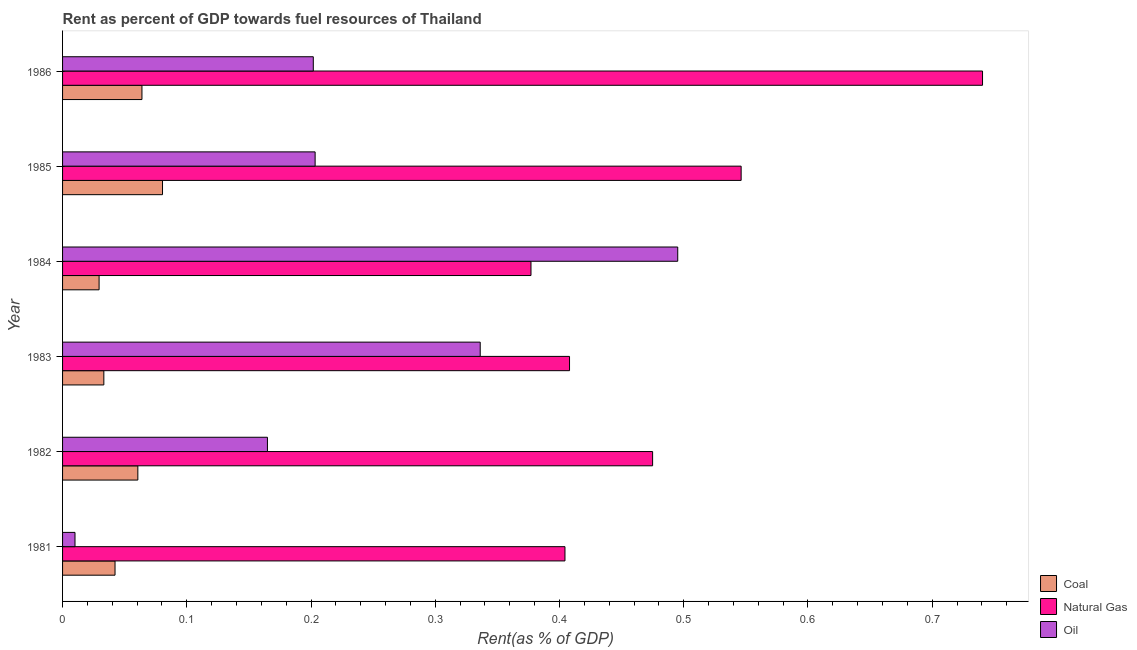How many different coloured bars are there?
Provide a short and direct response. 3. How many groups of bars are there?
Make the answer very short. 6. How many bars are there on the 5th tick from the top?
Make the answer very short. 3. In how many cases, is the number of bars for a given year not equal to the number of legend labels?
Make the answer very short. 0. What is the rent towards natural gas in 1983?
Give a very brief answer. 0.41. Across all years, what is the maximum rent towards oil?
Offer a very short reply. 0.5. Across all years, what is the minimum rent towards natural gas?
Your answer should be compact. 0.38. In which year was the rent towards oil minimum?
Give a very brief answer. 1981. What is the total rent towards coal in the graph?
Offer a terse response. 0.31. What is the difference between the rent towards coal in 1982 and that in 1983?
Provide a succinct answer. 0.03. What is the difference between the rent towards coal in 1984 and the rent towards oil in 1985?
Your answer should be very brief. -0.17. What is the average rent towards natural gas per year?
Give a very brief answer. 0.49. In the year 1981, what is the difference between the rent towards oil and rent towards coal?
Offer a terse response. -0.03. What is the ratio of the rent towards oil in 1982 to that in 1985?
Your response must be concise. 0.81. What is the difference between the highest and the second highest rent towards oil?
Your answer should be very brief. 0.16. What is the difference between the highest and the lowest rent towards natural gas?
Keep it short and to the point. 0.36. Is the sum of the rent towards natural gas in 1983 and 1985 greater than the maximum rent towards oil across all years?
Provide a succinct answer. Yes. What does the 2nd bar from the top in 1981 represents?
Keep it short and to the point. Natural Gas. What does the 2nd bar from the bottom in 1982 represents?
Keep it short and to the point. Natural Gas. Is it the case that in every year, the sum of the rent towards coal and rent towards natural gas is greater than the rent towards oil?
Your response must be concise. No. How many bars are there?
Your answer should be very brief. 18. Are all the bars in the graph horizontal?
Provide a short and direct response. Yes. How many years are there in the graph?
Provide a short and direct response. 6. What is the difference between two consecutive major ticks on the X-axis?
Give a very brief answer. 0.1. Are the values on the major ticks of X-axis written in scientific E-notation?
Keep it short and to the point. No. Does the graph contain any zero values?
Provide a succinct answer. No. Does the graph contain grids?
Your answer should be very brief. No. Where does the legend appear in the graph?
Make the answer very short. Bottom right. How are the legend labels stacked?
Provide a succinct answer. Vertical. What is the title of the graph?
Your answer should be compact. Rent as percent of GDP towards fuel resources of Thailand. What is the label or title of the X-axis?
Offer a terse response. Rent(as % of GDP). What is the label or title of the Y-axis?
Give a very brief answer. Year. What is the Rent(as % of GDP) of Coal in 1981?
Provide a short and direct response. 0.04. What is the Rent(as % of GDP) in Natural Gas in 1981?
Your answer should be compact. 0.4. What is the Rent(as % of GDP) of Oil in 1981?
Your answer should be compact. 0.01. What is the Rent(as % of GDP) of Coal in 1982?
Your answer should be very brief. 0.06. What is the Rent(as % of GDP) of Natural Gas in 1982?
Make the answer very short. 0.47. What is the Rent(as % of GDP) in Oil in 1982?
Make the answer very short. 0.16. What is the Rent(as % of GDP) in Coal in 1983?
Make the answer very short. 0.03. What is the Rent(as % of GDP) of Natural Gas in 1983?
Keep it short and to the point. 0.41. What is the Rent(as % of GDP) of Oil in 1983?
Make the answer very short. 0.34. What is the Rent(as % of GDP) of Coal in 1984?
Your answer should be compact. 0.03. What is the Rent(as % of GDP) of Natural Gas in 1984?
Your answer should be very brief. 0.38. What is the Rent(as % of GDP) of Oil in 1984?
Make the answer very short. 0.5. What is the Rent(as % of GDP) of Coal in 1985?
Keep it short and to the point. 0.08. What is the Rent(as % of GDP) of Natural Gas in 1985?
Keep it short and to the point. 0.55. What is the Rent(as % of GDP) in Oil in 1985?
Offer a very short reply. 0.2. What is the Rent(as % of GDP) of Coal in 1986?
Your response must be concise. 0.06. What is the Rent(as % of GDP) of Natural Gas in 1986?
Offer a terse response. 0.74. What is the Rent(as % of GDP) in Oil in 1986?
Your answer should be compact. 0.2. Across all years, what is the maximum Rent(as % of GDP) in Coal?
Keep it short and to the point. 0.08. Across all years, what is the maximum Rent(as % of GDP) in Natural Gas?
Provide a short and direct response. 0.74. Across all years, what is the maximum Rent(as % of GDP) in Oil?
Provide a short and direct response. 0.5. Across all years, what is the minimum Rent(as % of GDP) of Coal?
Provide a succinct answer. 0.03. Across all years, what is the minimum Rent(as % of GDP) in Natural Gas?
Keep it short and to the point. 0.38. Across all years, what is the minimum Rent(as % of GDP) in Oil?
Offer a terse response. 0.01. What is the total Rent(as % of GDP) in Coal in the graph?
Provide a short and direct response. 0.31. What is the total Rent(as % of GDP) in Natural Gas in the graph?
Make the answer very short. 2.95. What is the total Rent(as % of GDP) of Oil in the graph?
Keep it short and to the point. 1.41. What is the difference between the Rent(as % of GDP) of Coal in 1981 and that in 1982?
Make the answer very short. -0.02. What is the difference between the Rent(as % of GDP) of Natural Gas in 1981 and that in 1982?
Ensure brevity in your answer.  -0.07. What is the difference between the Rent(as % of GDP) of Oil in 1981 and that in 1982?
Ensure brevity in your answer.  -0.15. What is the difference between the Rent(as % of GDP) of Coal in 1981 and that in 1983?
Ensure brevity in your answer.  0.01. What is the difference between the Rent(as % of GDP) of Natural Gas in 1981 and that in 1983?
Your response must be concise. -0. What is the difference between the Rent(as % of GDP) of Oil in 1981 and that in 1983?
Ensure brevity in your answer.  -0.33. What is the difference between the Rent(as % of GDP) of Coal in 1981 and that in 1984?
Provide a succinct answer. 0.01. What is the difference between the Rent(as % of GDP) of Natural Gas in 1981 and that in 1984?
Your response must be concise. 0.03. What is the difference between the Rent(as % of GDP) in Oil in 1981 and that in 1984?
Make the answer very short. -0.49. What is the difference between the Rent(as % of GDP) of Coal in 1981 and that in 1985?
Your answer should be compact. -0.04. What is the difference between the Rent(as % of GDP) in Natural Gas in 1981 and that in 1985?
Offer a very short reply. -0.14. What is the difference between the Rent(as % of GDP) of Oil in 1981 and that in 1985?
Give a very brief answer. -0.19. What is the difference between the Rent(as % of GDP) in Coal in 1981 and that in 1986?
Provide a short and direct response. -0.02. What is the difference between the Rent(as % of GDP) of Natural Gas in 1981 and that in 1986?
Make the answer very short. -0.34. What is the difference between the Rent(as % of GDP) in Oil in 1981 and that in 1986?
Your answer should be compact. -0.19. What is the difference between the Rent(as % of GDP) in Coal in 1982 and that in 1983?
Your answer should be compact. 0.03. What is the difference between the Rent(as % of GDP) in Natural Gas in 1982 and that in 1983?
Your answer should be very brief. 0.07. What is the difference between the Rent(as % of GDP) in Oil in 1982 and that in 1983?
Your answer should be compact. -0.17. What is the difference between the Rent(as % of GDP) in Coal in 1982 and that in 1984?
Provide a short and direct response. 0.03. What is the difference between the Rent(as % of GDP) in Natural Gas in 1982 and that in 1984?
Offer a terse response. 0.1. What is the difference between the Rent(as % of GDP) in Oil in 1982 and that in 1984?
Offer a terse response. -0.33. What is the difference between the Rent(as % of GDP) in Coal in 1982 and that in 1985?
Make the answer very short. -0.02. What is the difference between the Rent(as % of GDP) in Natural Gas in 1982 and that in 1985?
Your answer should be compact. -0.07. What is the difference between the Rent(as % of GDP) of Oil in 1982 and that in 1985?
Keep it short and to the point. -0.04. What is the difference between the Rent(as % of GDP) of Coal in 1982 and that in 1986?
Make the answer very short. -0. What is the difference between the Rent(as % of GDP) in Natural Gas in 1982 and that in 1986?
Make the answer very short. -0.27. What is the difference between the Rent(as % of GDP) of Oil in 1982 and that in 1986?
Your answer should be compact. -0.04. What is the difference between the Rent(as % of GDP) of Coal in 1983 and that in 1984?
Provide a short and direct response. 0. What is the difference between the Rent(as % of GDP) in Natural Gas in 1983 and that in 1984?
Your answer should be very brief. 0.03. What is the difference between the Rent(as % of GDP) of Oil in 1983 and that in 1984?
Your response must be concise. -0.16. What is the difference between the Rent(as % of GDP) of Coal in 1983 and that in 1985?
Your answer should be compact. -0.05. What is the difference between the Rent(as % of GDP) of Natural Gas in 1983 and that in 1985?
Your response must be concise. -0.14. What is the difference between the Rent(as % of GDP) in Oil in 1983 and that in 1985?
Offer a terse response. 0.13. What is the difference between the Rent(as % of GDP) of Coal in 1983 and that in 1986?
Give a very brief answer. -0.03. What is the difference between the Rent(as % of GDP) in Natural Gas in 1983 and that in 1986?
Offer a terse response. -0.33. What is the difference between the Rent(as % of GDP) in Oil in 1983 and that in 1986?
Offer a very short reply. 0.13. What is the difference between the Rent(as % of GDP) in Coal in 1984 and that in 1985?
Offer a terse response. -0.05. What is the difference between the Rent(as % of GDP) in Natural Gas in 1984 and that in 1985?
Offer a terse response. -0.17. What is the difference between the Rent(as % of GDP) of Oil in 1984 and that in 1985?
Offer a terse response. 0.29. What is the difference between the Rent(as % of GDP) of Coal in 1984 and that in 1986?
Ensure brevity in your answer.  -0.03. What is the difference between the Rent(as % of GDP) in Natural Gas in 1984 and that in 1986?
Provide a succinct answer. -0.36. What is the difference between the Rent(as % of GDP) in Oil in 1984 and that in 1986?
Your answer should be very brief. 0.29. What is the difference between the Rent(as % of GDP) of Coal in 1985 and that in 1986?
Your response must be concise. 0.02. What is the difference between the Rent(as % of GDP) in Natural Gas in 1985 and that in 1986?
Give a very brief answer. -0.19. What is the difference between the Rent(as % of GDP) of Oil in 1985 and that in 1986?
Your answer should be compact. 0. What is the difference between the Rent(as % of GDP) of Coal in 1981 and the Rent(as % of GDP) of Natural Gas in 1982?
Offer a very short reply. -0.43. What is the difference between the Rent(as % of GDP) of Coal in 1981 and the Rent(as % of GDP) of Oil in 1982?
Provide a succinct answer. -0.12. What is the difference between the Rent(as % of GDP) in Natural Gas in 1981 and the Rent(as % of GDP) in Oil in 1982?
Keep it short and to the point. 0.24. What is the difference between the Rent(as % of GDP) of Coal in 1981 and the Rent(as % of GDP) of Natural Gas in 1983?
Your response must be concise. -0.37. What is the difference between the Rent(as % of GDP) in Coal in 1981 and the Rent(as % of GDP) in Oil in 1983?
Your answer should be compact. -0.29. What is the difference between the Rent(as % of GDP) in Natural Gas in 1981 and the Rent(as % of GDP) in Oil in 1983?
Provide a succinct answer. 0.07. What is the difference between the Rent(as % of GDP) in Coal in 1981 and the Rent(as % of GDP) in Natural Gas in 1984?
Provide a short and direct response. -0.33. What is the difference between the Rent(as % of GDP) in Coal in 1981 and the Rent(as % of GDP) in Oil in 1984?
Offer a very short reply. -0.45. What is the difference between the Rent(as % of GDP) of Natural Gas in 1981 and the Rent(as % of GDP) of Oil in 1984?
Provide a short and direct response. -0.09. What is the difference between the Rent(as % of GDP) in Coal in 1981 and the Rent(as % of GDP) in Natural Gas in 1985?
Provide a succinct answer. -0.5. What is the difference between the Rent(as % of GDP) of Coal in 1981 and the Rent(as % of GDP) of Oil in 1985?
Keep it short and to the point. -0.16. What is the difference between the Rent(as % of GDP) in Natural Gas in 1981 and the Rent(as % of GDP) in Oil in 1985?
Offer a terse response. 0.2. What is the difference between the Rent(as % of GDP) in Coal in 1981 and the Rent(as % of GDP) in Natural Gas in 1986?
Keep it short and to the point. -0.7. What is the difference between the Rent(as % of GDP) in Coal in 1981 and the Rent(as % of GDP) in Oil in 1986?
Offer a very short reply. -0.16. What is the difference between the Rent(as % of GDP) in Natural Gas in 1981 and the Rent(as % of GDP) in Oil in 1986?
Your response must be concise. 0.2. What is the difference between the Rent(as % of GDP) of Coal in 1982 and the Rent(as % of GDP) of Natural Gas in 1983?
Provide a short and direct response. -0.35. What is the difference between the Rent(as % of GDP) of Coal in 1982 and the Rent(as % of GDP) of Oil in 1983?
Your answer should be very brief. -0.28. What is the difference between the Rent(as % of GDP) in Natural Gas in 1982 and the Rent(as % of GDP) in Oil in 1983?
Make the answer very short. 0.14. What is the difference between the Rent(as % of GDP) in Coal in 1982 and the Rent(as % of GDP) in Natural Gas in 1984?
Make the answer very short. -0.32. What is the difference between the Rent(as % of GDP) in Coal in 1982 and the Rent(as % of GDP) in Oil in 1984?
Provide a short and direct response. -0.43. What is the difference between the Rent(as % of GDP) of Natural Gas in 1982 and the Rent(as % of GDP) of Oil in 1984?
Give a very brief answer. -0.02. What is the difference between the Rent(as % of GDP) of Coal in 1982 and the Rent(as % of GDP) of Natural Gas in 1985?
Make the answer very short. -0.49. What is the difference between the Rent(as % of GDP) of Coal in 1982 and the Rent(as % of GDP) of Oil in 1985?
Provide a short and direct response. -0.14. What is the difference between the Rent(as % of GDP) in Natural Gas in 1982 and the Rent(as % of GDP) in Oil in 1985?
Provide a succinct answer. 0.27. What is the difference between the Rent(as % of GDP) of Coal in 1982 and the Rent(as % of GDP) of Natural Gas in 1986?
Your answer should be very brief. -0.68. What is the difference between the Rent(as % of GDP) in Coal in 1982 and the Rent(as % of GDP) in Oil in 1986?
Make the answer very short. -0.14. What is the difference between the Rent(as % of GDP) in Natural Gas in 1982 and the Rent(as % of GDP) in Oil in 1986?
Your response must be concise. 0.27. What is the difference between the Rent(as % of GDP) in Coal in 1983 and the Rent(as % of GDP) in Natural Gas in 1984?
Your answer should be compact. -0.34. What is the difference between the Rent(as % of GDP) in Coal in 1983 and the Rent(as % of GDP) in Oil in 1984?
Your answer should be compact. -0.46. What is the difference between the Rent(as % of GDP) of Natural Gas in 1983 and the Rent(as % of GDP) of Oil in 1984?
Make the answer very short. -0.09. What is the difference between the Rent(as % of GDP) of Coal in 1983 and the Rent(as % of GDP) of Natural Gas in 1985?
Your answer should be very brief. -0.51. What is the difference between the Rent(as % of GDP) in Coal in 1983 and the Rent(as % of GDP) in Oil in 1985?
Offer a very short reply. -0.17. What is the difference between the Rent(as % of GDP) of Natural Gas in 1983 and the Rent(as % of GDP) of Oil in 1985?
Offer a terse response. 0.2. What is the difference between the Rent(as % of GDP) of Coal in 1983 and the Rent(as % of GDP) of Natural Gas in 1986?
Your answer should be compact. -0.71. What is the difference between the Rent(as % of GDP) of Coal in 1983 and the Rent(as % of GDP) of Oil in 1986?
Keep it short and to the point. -0.17. What is the difference between the Rent(as % of GDP) of Natural Gas in 1983 and the Rent(as % of GDP) of Oil in 1986?
Make the answer very short. 0.21. What is the difference between the Rent(as % of GDP) in Coal in 1984 and the Rent(as % of GDP) in Natural Gas in 1985?
Offer a very short reply. -0.52. What is the difference between the Rent(as % of GDP) of Coal in 1984 and the Rent(as % of GDP) of Oil in 1985?
Give a very brief answer. -0.17. What is the difference between the Rent(as % of GDP) of Natural Gas in 1984 and the Rent(as % of GDP) of Oil in 1985?
Offer a very short reply. 0.17. What is the difference between the Rent(as % of GDP) in Coal in 1984 and the Rent(as % of GDP) in Natural Gas in 1986?
Provide a succinct answer. -0.71. What is the difference between the Rent(as % of GDP) in Coal in 1984 and the Rent(as % of GDP) in Oil in 1986?
Your answer should be compact. -0.17. What is the difference between the Rent(as % of GDP) of Natural Gas in 1984 and the Rent(as % of GDP) of Oil in 1986?
Offer a terse response. 0.18. What is the difference between the Rent(as % of GDP) of Coal in 1985 and the Rent(as % of GDP) of Natural Gas in 1986?
Your answer should be compact. -0.66. What is the difference between the Rent(as % of GDP) of Coal in 1985 and the Rent(as % of GDP) of Oil in 1986?
Keep it short and to the point. -0.12. What is the difference between the Rent(as % of GDP) in Natural Gas in 1985 and the Rent(as % of GDP) in Oil in 1986?
Provide a short and direct response. 0.34. What is the average Rent(as % of GDP) of Coal per year?
Make the answer very short. 0.05. What is the average Rent(as % of GDP) of Natural Gas per year?
Your response must be concise. 0.49. What is the average Rent(as % of GDP) of Oil per year?
Make the answer very short. 0.24. In the year 1981, what is the difference between the Rent(as % of GDP) in Coal and Rent(as % of GDP) in Natural Gas?
Keep it short and to the point. -0.36. In the year 1981, what is the difference between the Rent(as % of GDP) in Coal and Rent(as % of GDP) in Oil?
Make the answer very short. 0.03. In the year 1981, what is the difference between the Rent(as % of GDP) of Natural Gas and Rent(as % of GDP) of Oil?
Your answer should be compact. 0.39. In the year 1982, what is the difference between the Rent(as % of GDP) of Coal and Rent(as % of GDP) of Natural Gas?
Your answer should be compact. -0.41. In the year 1982, what is the difference between the Rent(as % of GDP) in Coal and Rent(as % of GDP) in Oil?
Offer a very short reply. -0.1. In the year 1982, what is the difference between the Rent(as % of GDP) in Natural Gas and Rent(as % of GDP) in Oil?
Offer a very short reply. 0.31. In the year 1983, what is the difference between the Rent(as % of GDP) of Coal and Rent(as % of GDP) of Natural Gas?
Offer a terse response. -0.37. In the year 1983, what is the difference between the Rent(as % of GDP) in Coal and Rent(as % of GDP) in Oil?
Give a very brief answer. -0.3. In the year 1983, what is the difference between the Rent(as % of GDP) in Natural Gas and Rent(as % of GDP) in Oil?
Your answer should be compact. 0.07. In the year 1984, what is the difference between the Rent(as % of GDP) of Coal and Rent(as % of GDP) of Natural Gas?
Offer a very short reply. -0.35. In the year 1984, what is the difference between the Rent(as % of GDP) of Coal and Rent(as % of GDP) of Oil?
Provide a succinct answer. -0.47. In the year 1984, what is the difference between the Rent(as % of GDP) of Natural Gas and Rent(as % of GDP) of Oil?
Give a very brief answer. -0.12. In the year 1985, what is the difference between the Rent(as % of GDP) of Coal and Rent(as % of GDP) of Natural Gas?
Give a very brief answer. -0.47. In the year 1985, what is the difference between the Rent(as % of GDP) of Coal and Rent(as % of GDP) of Oil?
Your answer should be compact. -0.12. In the year 1985, what is the difference between the Rent(as % of GDP) of Natural Gas and Rent(as % of GDP) of Oil?
Your response must be concise. 0.34. In the year 1986, what is the difference between the Rent(as % of GDP) in Coal and Rent(as % of GDP) in Natural Gas?
Give a very brief answer. -0.68. In the year 1986, what is the difference between the Rent(as % of GDP) in Coal and Rent(as % of GDP) in Oil?
Provide a succinct answer. -0.14. In the year 1986, what is the difference between the Rent(as % of GDP) in Natural Gas and Rent(as % of GDP) in Oil?
Make the answer very short. 0.54. What is the ratio of the Rent(as % of GDP) in Coal in 1981 to that in 1982?
Give a very brief answer. 0.7. What is the ratio of the Rent(as % of GDP) of Natural Gas in 1981 to that in 1982?
Offer a very short reply. 0.85. What is the ratio of the Rent(as % of GDP) in Oil in 1981 to that in 1982?
Your response must be concise. 0.06. What is the ratio of the Rent(as % of GDP) in Coal in 1981 to that in 1983?
Ensure brevity in your answer.  1.27. What is the ratio of the Rent(as % of GDP) of Natural Gas in 1981 to that in 1983?
Your answer should be compact. 0.99. What is the ratio of the Rent(as % of GDP) in Oil in 1981 to that in 1983?
Your answer should be very brief. 0.03. What is the ratio of the Rent(as % of GDP) of Coal in 1981 to that in 1984?
Your answer should be very brief. 1.44. What is the ratio of the Rent(as % of GDP) of Natural Gas in 1981 to that in 1984?
Provide a succinct answer. 1.07. What is the ratio of the Rent(as % of GDP) of Oil in 1981 to that in 1984?
Offer a very short reply. 0.02. What is the ratio of the Rent(as % of GDP) in Coal in 1981 to that in 1985?
Your answer should be compact. 0.53. What is the ratio of the Rent(as % of GDP) of Natural Gas in 1981 to that in 1985?
Provide a succinct answer. 0.74. What is the ratio of the Rent(as % of GDP) in Oil in 1981 to that in 1985?
Your answer should be compact. 0.05. What is the ratio of the Rent(as % of GDP) in Coal in 1981 to that in 1986?
Provide a short and direct response. 0.66. What is the ratio of the Rent(as % of GDP) of Natural Gas in 1981 to that in 1986?
Offer a very short reply. 0.55. What is the ratio of the Rent(as % of GDP) in Oil in 1981 to that in 1986?
Offer a terse response. 0.05. What is the ratio of the Rent(as % of GDP) of Coal in 1982 to that in 1983?
Make the answer very short. 1.82. What is the ratio of the Rent(as % of GDP) of Natural Gas in 1982 to that in 1983?
Provide a short and direct response. 1.16. What is the ratio of the Rent(as % of GDP) of Oil in 1982 to that in 1983?
Offer a very short reply. 0.49. What is the ratio of the Rent(as % of GDP) of Coal in 1982 to that in 1984?
Provide a succinct answer. 2.06. What is the ratio of the Rent(as % of GDP) of Natural Gas in 1982 to that in 1984?
Your answer should be very brief. 1.26. What is the ratio of the Rent(as % of GDP) of Oil in 1982 to that in 1984?
Keep it short and to the point. 0.33. What is the ratio of the Rent(as % of GDP) of Coal in 1982 to that in 1985?
Provide a succinct answer. 0.75. What is the ratio of the Rent(as % of GDP) in Natural Gas in 1982 to that in 1985?
Offer a terse response. 0.87. What is the ratio of the Rent(as % of GDP) in Oil in 1982 to that in 1985?
Offer a very short reply. 0.81. What is the ratio of the Rent(as % of GDP) in Coal in 1982 to that in 1986?
Provide a succinct answer. 0.95. What is the ratio of the Rent(as % of GDP) of Natural Gas in 1982 to that in 1986?
Offer a very short reply. 0.64. What is the ratio of the Rent(as % of GDP) of Oil in 1982 to that in 1986?
Offer a very short reply. 0.82. What is the ratio of the Rent(as % of GDP) of Coal in 1983 to that in 1984?
Provide a short and direct response. 1.13. What is the ratio of the Rent(as % of GDP) in Natural Gas in 1983 to that in 1984?
Keep it short and to the point. 1.08. What is the ratio of the Rent(as % of GDP) in Oil in 1983 to that in 1984?
Your answer should be compact. 0.68. What is the ratio of the Rent(as % of GDP) in Coal in 1983 to that in 1985?
Provide a short and direct response. 0.41. What is the ratio of the Rent(as % of GDP) of Natural Gas in 1983 to that in 1985?
Your answer should be very brief. 0.75. What is the ratio of the Rent(as % of GDP) of Oil in 1983 to that in 1985?
Offer a very short reply. 1.65. What is the ratio of the Rent(as % of GDP) of Coal in 1983 to that in 1986?
Offer a terse response. 0.52. What is the ratio of the Rent(as % of GDP) of Natural Gas in 1983 to that in 1986?
Your answer should be very brief. 0.55. What is the ratio of the Rent(as % of GDP) of Oil in 1983 to that in 1986?
Provide a short and direct response. 1.67. What is the ratio of the Rent(as % of GDP) of Coal in 1984 to that in 1985?
Ensure brevity in your answer.  0.37. What is the ratio of the Rent(as % of GDP) of Natural Gas in 1984 to that in 1985?
Provide a succinct answer. 0.69. What is the ratio of the Rent(as % of GDP) of Oil in 1984 to that in 1985?
Ensure brevity in your answer.  2.44. What is the ratio of the Rent(as % of GDP) in Coal in 1984 to that in 1986?
Provide a short and direct response. 0.46. What is the ratio of the Rent(as % of GDP) of Natural Gas in 1984 to that in 1986?
Ensure brevity in your answer.  0.51. What is the ratio of the Rent(as % of GDP) of Oil in 1984 to that in 1986?
Provide a succinct answer. 2.45. What is the ratio of the Rent(as % of GDP) of Coal in 1985 to that in 1986?
Provide a short and direct response. 1.26. What is the ratio of the Rent(as % of GDP) in Natural Gas in 1985 to that in 1986?
Make the answer very short. 0.74. What is the ratio of the Rent(as % of GDP) of Oil in 1985 to that in 1986?
Give a very brief answer. 1.01. What is the difference between the highest and the second highest Rent(as % of GDP) in Coal?
Provide a succinct answer. 0.02. What is the difference between the highest and the second highest Rent(as % of GDP) in Natural Gas?
Your response must be concise. 0.19. What is the difference between the highest and the second highest Rent(as % of GDP) in Oil?
Make the answer very short. 0.16. What is the difference between the highest and the lowest Rent(as % of GDP) in Coal?
Your answer should be very brief. 0.05. What is the difference between the highest and the lowest Rent(as % of GDP) in Natural Gas?
Give a very brief answer. 0.36. What is the difference between the highest and the lowest Rent(as % of GDP) of Oil?
Offer a very short reply. 0.49. 